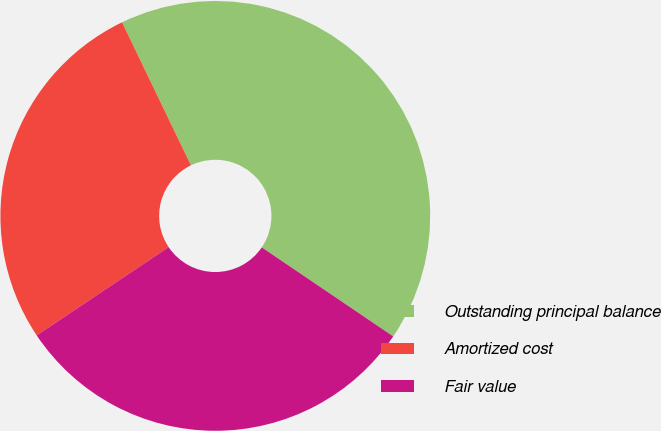<chart> <loc_0><loc_0><loc_500><loc_500><pie_chart><fcel>Outstanding principal balance<fcel>Amortized cost<fcel>Fair value<nl><fcel>41.62%<fcel>27.24%<fcel>31.14%<nl></chart> 